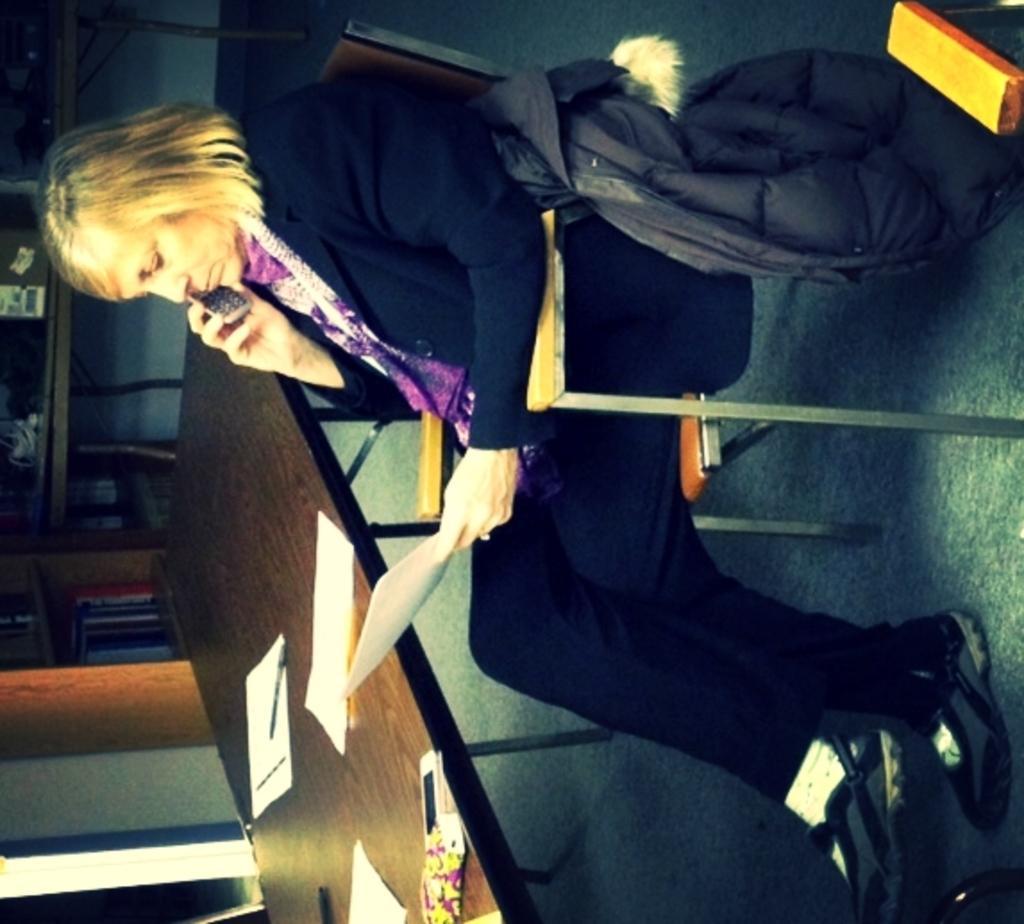How would you summarize this image in a sentence or two? In the center of the image we can see a lady is sitting on a chair and holding a paper, mobile. On the right side of the image we can see a bag and an object. On the left side of the image we can see the tables, rack. On the tables we can see the papers, mobile, pens and some other objects. In the rack we can see the books. In the background of the image we can see the floor and wall. 